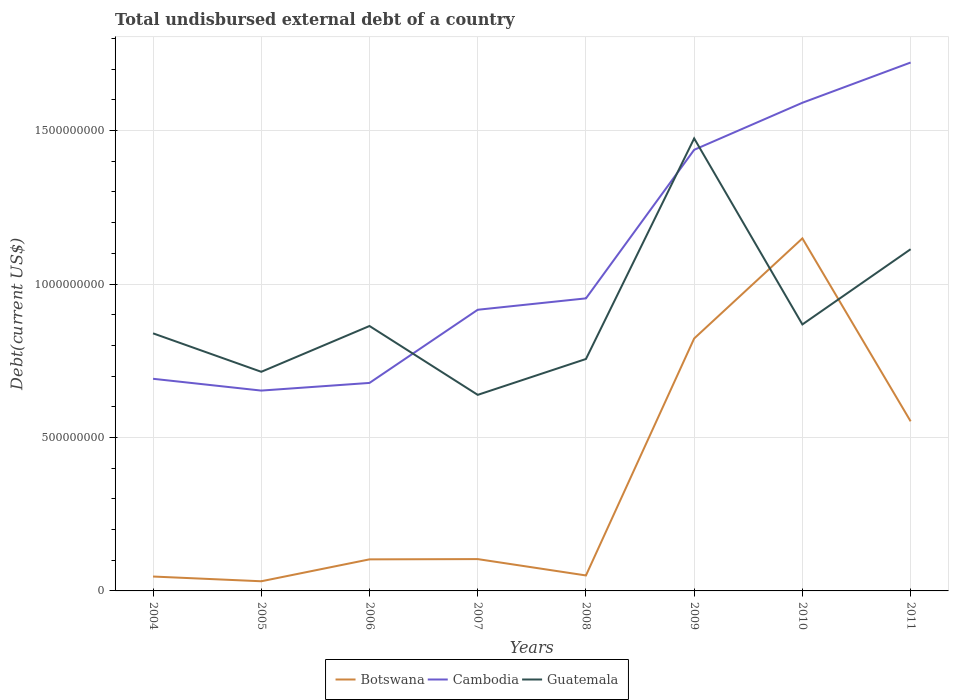Does the line corresponding to Botswana intersect with the line corresponding to Guatemala?
Make the answer very short. Yes. Across all years, what is the maximum total undisbursed external debt in Botswana?
Give a very brief answer. 3.15e+07. In which year was the total undisbursed external debt in Guatemala maximum?
Provide a succinct answer. 2007. What is the total total undisbursed external debt in Guatemala in the graph?
Your answer should be compact. -1.54e+08. What is the difference between the highest and the second highest total undisbursed external debt in Guatemala?
Offer a very short reply. 8.36e+08. How many years are there in the graph?
Offer a terse response. 8. Are the values on the major ticks of Y-axis written in scientific E-notation?
Ensure brevity in your answer.  No. Does the graph contain any zero values?
Provide a short and direct response. No. Where does the legend appear in the graph?
Offer a very short reply. Bottom center. How are the legend labels stacked?
Provide a short and direct response. Horizontal. What is the title of the graph?
Provide a short and direct response. Total undisbursed external debt of a country. What is the label or title of the X-axis?
Keep it short and to the point. Years. What is the label or title of the Y-axis?
Offer a terse response. Debt(current US$). What is the Debt(current US$) in Botswana in 2004?
Offer a very short reply. 4.69e+07. What is the Debt(current US$) of Cambodia in 2004?
Your response must be concise. 6.91e+08. What is the Debt(current US$) in Guatemala in 2004?
Offer a terse response. 8.39e+08. What is the Debt(current US$) in Botswana in 2005?
Make the answer very short. 3.15e+07. What is the Debt(current US$) of Cambodia in 2005?
Give a very brief answer. 6.53e+08. What is the Debt(current US$) in Guatemala in 2005?
Your response must be concise. 7.14e+08. What is the Debt(current US$) in Botswana in 2006?
Your answer should be compact. 1.03e+08. What is the Debt(current US$) in Cambodia in 2006?
Keep it short and to the point. 6.78e+08. What is the Debt(current US$) in Guatemala in 2006?
Offer a terse response. 8.63e+08. What is the Debt(current US$) in Botswana in 2007?
Provide a succinct answer. 1.04e+08. What is the Debt(current US$) of Cambodia in 2007?
Offer a very short reply. 9.16e+08. What is the Debt(current US$) in Guatemala in 2007?
Provide a short and direct response. 6.39e+08. What is the Debt(current US$) of Botswana in 2008?
Ensure brevity in your answer.  5.04e+07. What is the Debt(current US$) of Cambodia in 2008?
Your answer should be compact. 9.53e+08. What is the Debt(current US$) in Guatemala in 2008?
Your answer should be compact. 7.56e+08. What is the Debt(current US$) in Botswana in 2009?
Your answer should be very brief. 8.23e+08. What is the Debt(current US$) of Cambodia in 2009?
Offer a terse response. 1.44e+09. What is the Debt(current US$) in Guatemala in 2009?
Make the answer very short. 1.47e+09. What is the Debt(current US$) in Botswana in 2010?
Keep it short and to the point. 1.15e+09. What is the Debt(current US$) of Cambodia in 2010?
Your answer should be very brief. 1.59e+09. What is the Debt(current US$) of Guatemala in 2010?
Provide a short and direct response. 8.68e+08. What is the Debt(current US$) in Botswana in 2011?
Provide a short and direct response. 5.53e+08. What is the Debt(current US$) in Cambodia in 2011?
Offer a terse response. 1.72e+09. What is the Debt(current US$) in Guatemala in 2011?
Offer a terse response. 1.11e+09. Across all years, what is the maximum Debt(current US$) in Botswana?
Offer a very short reply. 1.15e+09. Across all years, what is the maximum Debt(current US$) in Cambodia?
Your answer should be very brief. 1.72e+09. Across all years, what is the maximum Debt(current US$) in Guatemala?
Your answer should be very brief. 1.47e+09. Across all years, what is the minimum Debt(current US$) in Botswana?
Offer a terse response. 3.15e+07. Across all years, what is the minimum Debt(current US$) of Cambodia?
Keep it short and to the point. 6.53e+08. Across all years, what is the minimum Debt(current US$) of Guatemala?
Offer a terse response. 6.39e+08. What is the total Debt(current US$) in Botswana in the graph?
Your response must be concise. 2.86e+09. What is the total Debt(current US$) in Cambodia in the graph?
Your response must be concise. 8.64e+09. What is the total Debt(current US$) in Guatemala in the graph?
Provide a succinct answer. 7.27e+09. What is the difference between the Debt(current US$) in Botswana in 2004 and that in 2005?
Provide a short and direct response. 1.54e+07. What is the difference between the Debt(current US$) in Cambodia in 2004 and that in 2005?
Offer a very short reply. 3.84e+07. What is the difference between the Debt(current US$) of Guatemala in 2004 and that in 2005?
Provide a succinct answer. 1.25e+08. What is the difference between the Debt(current US$) in Botswana in 2004 and that in 2006?
Provide a succinct answer. -5.59e+07. What is the difference between the Debt(current US$) in Cambodia in 2004 and that in 2006?
Provide a short and direct response. 1.35e+07. What is the difference between the Debt(current US$) in Guatemala in 2004 and that in 2006?
Provide a short and direct response. -2.39e+07. What is the difference between the Debt(current US$) in Botswana in 2004 and that in 2007?
Make the answer very short. -5.68e+07. What is the difference between the Debt(current US$) of Cambodia in 2004 and that in 2007?
Offer a very short reply. -2.25e+08. What is the difference between the Debt(current US$) of Guatemala in 2004 and that in 2007?
Your answer should be compact. 2.00e+08. What is the difference between the Debt(current US$) of Botswana in 2004 and that in 2008?
Provide a succinct answer. -3.52e+06. What is the difference between the Debt(current US$) of Cambodia in 2004 and that in 2008?
Your response must be concise. -2.62e+08. What is the difference between the Debt(current US$) of Guatemala in 2004 and that in 2008?
Give a very brief answer. 8.36e+07. What is the difference between the Debt(current US$) of Botswana in 2004 and that in 2009?
Make the answer very short. -7.76e+08. What is the difference between the Debt(current US$) in Cambodia in 2004 and that in 2009?
Your answer should be compact. -7.46e+08. What is the difference between the Debt(current US$) of Guatemala in 2004 and that in 2009?
Ensure brevity in your answer.  -6.35e+08. What is the difference between the Debt(current US$) of Botswana in 2004 and that in 2010?
Provide a short and direct response. -1.10e+09. What is the difference between the Debt(current US$) in Cambodia in 2004 and that in 2010?
Offer a very short reply. -8.99e+08. What is the difference between the Debt(current US$) of Guatemala in 2004 and that in 2010?
Provide a succinct answer. -2.90e+07. What is the difference between the Debt(current US$) in Botswana in 2004 and that in 2011?
Your answer should be very brief. -5.06e+08. What is the difference between the Debt(current US$) of Cambodia in 2004 and that in 2011?
Your answer should be very brief. -1.03e+09. What is the difference between the Debt(current US$) in Guatemala in 2004 and that in 2011?
Make the answer very short. -2.74e+08. What is the difference between the Debt(current US$) in Botswana in 2005 and that in 2006?
Your answer should be compact. -7.14e+07. What is the difference between the Debt(current US$) of Cambodia in 2005 and that in 2006?
Your response must be concise. -2.49e+07. What is the difference between the Debt(current US$) of Guatemala in 2005 and that in 2006?
Provide a short and direct response. -1.49e+08. What is the difference between the Debt(current US$) in Botswana in 2005 and that in 2007?
Ensure brevity in your answer.  -7.22e+07. What is the difference between the Debt(current US$) in Cambodia in 2005 and that in 2007?
Keep it short and to the point. -2.63e+08. What is the difference between the Debt(current US$) of Guatemala in 2005 and that in 2007?
Provide a succinct answer. 7.51e+07. What is the difference between the Debt(current US$) of Botswana in 2005 and that in 2008?
Your response must be concise. -1.90e+07. What is the difference between the Debt(current US$) of Cambodia in 2005 and that in 2008?
Keep it short and to the point. -3.00e+08. What is the difference between the Debt(current US$) in Guatemala in 2005 and that in 2008?
Ensure brevity in your answer.  -4.17e+07. What is the difference between the Debt(current US$) of Botswana in 2005 and that in 2009?
Keep it short and to the point. -7.91e+08. What is the difference between the Debt(current US$) in Cambodia in 2005 and that in 2009?
Keep it short and to the point. -7.85e+08. What is the difference between the Debt(current US$) in Guatemala in 2005 and that in 2009?
Keep it short and to the point. -7.60e+08. What is the difference between the Debt(current US$) of Botswana in 2005 and that in 2010?
Offer a very short reply. -1.12e+09. What is the difference between the Debt(current US$) of Cambodia in 2005 and that in 2010?
Provide a succinct answer. -9.38e+08. What is the difference between the Debt(current US$) of Guatemala in 2005 and that in 2010?
Your answer should be very brief. -1.54e+08. What is the difference between the Debt(current US$) of Botswana in 2005 and that in 2011?
Make the answer very short. -5.21e+08. What is the difference between the Debt(current US$) in Cambodia in 2005 and that in 2011?
Provide a succinct answer. -1.07e+09. What is the difference between the Debt(current US$) in Guatemala in 2005 and that in 2011?
Provide a succinct answer. -3.99e+08. What is the difference between the Debt(current US$) in Botswana in 2006 and that in 2007?
Give a very brief answer. -8.49e+05. What is the difference between the Debt(current US$) in Cambodia in 2006 and that in 2007?
Keep it short and to the point. -2.38e+08. What is the difference between the Debt(current US$) in Guatemala in 2006 and that in 2007?
Ensure brevity in your answer.  2.24e+08. What is the difference between the Debt(current US$) in Botswana in 2006 and that in 2008?
Provide a short and direct response. 5.24e+07. What is the difference between the Debt(current US$) of Cambodia in 2006 and that in 2008?
Offer a very short reply. -2.76e+08. What is the difference between the Debt(current US$) in Guatemala in 2006 and that in 2008?
Give a very brief answer. 1.08e+08. What is the difference between the Debt(current US$) of Botswana in 2006 and that in 2009?
Ensure brevity in your answer.  -7.20e+08. What is the difference between the Debt(current US$) in Cambodia in 2006 and that in 2009?
Provide a short and direct response. -7.60e+08. What is the difference between the Debt(current US$) in Guatemala in 2006 and that in 2009?
Your answer should be compact. -6.11e+08. What is the difference between the Debt(current US$) in Botswana in 2006 and that in 2010?
Give a very brief answer. -1.05e+09. What is the difference between the Debt(current US$) in Cambodia in 2006 and that in 2010?
Give a very brief answer. -9.13e+08. What is the difference between the Debt(current US$) of Guatemala in 2006 and that in 2010?
Your answer should be very brief. -5.10e+06. What is the difference between the Debt(current US$) of Botswana in 2006 and that in 2011?
Offer a very short reply. -4.50e+08. What is the difference between the Debt(current US$) in Cambodia in 2006 and that in 2011?
Offer a terse response. -1.04e+09. What is the difference between the Debt(current US$) of Guatemala in 2006 and that in 2011?
Keep it short and to the point. -2.50e+08. What is the difference between the Debt(current US$) of Botswana in 2007 and that in 2008?
Keep it short and to the point. 5.33e+07. What is the difference between the Debt(current US$) of Cambodia in 2007 and that in 2008?
Make the answer very short. -3.71e+07. What is the difference between the Debt(current US$) of Guatemala in 2007 and that in 2008?
Your response must be concise. -1.17e+08. What is the difference between the Debt(current US$) in Botswana in 2007 and that in 2009?
Provide a short and direct response. -7.19e+08. What is the difference between the Debt(current US$) in Cambodia in 2007 and that in 2009?
Your answer should be compact. -5.21e+08. What is the difference between the Debt(current US$) of Guatemala in 2007 and that in 2009?
Offer a very short reply. -8.36e+08. What is the difference between the Debt(current US$) in Botswana in 2007 and that in 2010?
Provide a succinct answer. -1.05e+09. What is the difference between the Debt(current US$) of Cambodia in 2007 and that in 2010?
Keep it short and to the point. -6.74e+08. What is the difference between the Debt(current US$) in Guatemala in 2007 and that in 2010?
Offer a terse response. -2.29e+08. What is the difference between the Debt(current US$) of Botswana in 2007 and that in 2011?
Offer a terse response. -4.49e+08. What is the difference between the Debt(current US$) in Cambodia in 2007 and that in 2011?
Make the answer very short. -8.06e+08. What is the difference between the Debt(current US$) in Guatemala in 2007 and that in 2011?
Offer a terse response. -4.75e+08. What is the difference between the Debt(current US$) of Botswana in 2008 and that in 2009?
Your answer should be very brief. -7.72e+08. What is the difference between the Debt(current US$) in Cambodia in 2008 and that in 2009?
Your answer should be compact. -4.84e+08. What is the difference between the Debt(current US$) in Guatemala in 2008 and that in 2009?
Make the answer very short. -7.19e+08. What is the difference between the Debt(current US$) in Botswana in 2008 and that in 2010?
Your answer should be compact. -1.10e+09. What is the difference between the Debt(current US$) in Cambodia in 2008 and that in 2010?
Your answer should be very brief. -6.37e+08. What is the difference between the Debt(current US$) of Guatemala in 2008 and that in 2010?
Give a very brief answer. -1.13e+08. What is the difference between the Debt(current US$) in Botswana in 2008 and that in 2011?
Your response must be concise. -5.02e+08. What is the difference between the Debt(current US$) in Cambodia in 2008 and that in 2011?
Keep it short and to the point. -7.68e+08. What is the difference between the Debt(current US$) of Guatemala in 2008 and that in 2011?
Provide a short and direct response. -3.58e+08. What is the difference between the Debt(current US$) in Botswana in 2009 and that in 2010?
Ensure brevity in your answer.  -3.26e+08. What is the difference between the Debt(current US$) of Cambodia in 2009 and that in 2010?
Offer a very short reply. -1.53e+08. What is the difference between the Debt(current US$) in Guatemala in 2009 and that in 2010?
Ensure brevity in your answer.  6.06e+08. What is the difference between the Debt(current US$) of Botswana in 2009 and that in 2011?
Make the answer very short. 2.70e+08. What is the difference between the Debt(current US$) of Cambodia in 2009 and that in 2011?
Make the answer very short. -2.84e+08. What is the difference between the Debt(current US$) of Guatemala in 2009 and that in 2011?
Your response must be concise. 3.61e+08. What is the difference between the Debt(current US$) in Botswana in 2010 and that in 2011?
Provide a short and direct response. 5.96e+08. What is the difference between the Debt(current US$) of Cambodia in 2010 and that in 2011?
Offer a terse response. -1.31e+08. What is the difference between the Debt(current US$) of Guatemala in 2010 and that in 2011?
Provide a short and direct response. -2.45e+08. What is the difference between the Debt(current US$) of Botswana in 2004 and the Debt(current US$) of Cambodia in 2005?
Give a very brief answer. -6.06e+08. What is the difference between the Debt(current US$) of Botswana in 2004 and the Debt(current US$) of Guatemala in 2005?
Give a very brief answer. -6.67e+08. What is the difference between the Debt(current US$) of Cambodia in 2004 and the Debt(current US$) of Guatemala in 2005?
Ensure brevity in your answer.  -2.28e+07. What is the difference between the Debt(current US$) of Botswana in 2004 and the Debt(current US$) of Cambodia in 2006?
Provide a succinct answer. -6.31e+08. What is the difference between the Debt(current US$) in Botswana in 2004 and the Debt(current US$) in Guatemala in 2006?
Make the answer very short. -8.16e+08. What is the difference between the Debt(current US$) in Cambodia in 2004 and the Debt(current US$) in Guatemala in 2006?
Your answer should be compact. -1.72e+08. What is the difference between the Debt(current US$) of Botswana in 2004 and the Debt(current US$) of Cambodia in 2007?
Give a very brief answer. -8.69e+08. What is the difference between the Debt(current US$) in Botswana in 2004 and the Debt(current US$) in Guatemala in 2007?
Give a very brief answer. -5.92e+08. What is the difference between the Debt(current US$) in Cambodia in 2004 and the Debt(current US$) in Guatemala in 2007?
Offer a terse response. 5.24e+07. What is the difference between the Debt(current US$) in Botswana in 2004 and the Debt(current US$) in Cambodia in 2008?
Keep it short and to the point. -9.06e+08. What is the difference between the Debt(current US$) of Botswana in 2004 and the Debt(current US$) of Guatemala in 2008?
Provide a succinct answer. -7.09e+08. What is the difference between the Debt(current US$) in Cambodia in 2004 and the Debt(current US$) in Guatemala in 2008?
Ensure brevity in your answer.  -6.45e+07. What is the difference between the Debt(current US$) of Botswana in 2004 and the Debt(current US$) of Cambodia in 2009?
Your answer should be compact. -1.39e+09. What is the difference between the Debt(current US$) in Botswana in 2004 and the Debt(current US$) in Guatemala in 2009?
Offer a terse response. -1.43e+09. What is the difference between the Debt(current US$) of Cambodia in 2004 and the Debt(current US$) of Guatemala in 2009?
Your answer should be compact. -7.83e+08. What is the difference between the Debt(current US$) of Botswana in 2004 and the Debt(current US$) of Cambodia in 2010?
Provide a short and direct response. -1.54e+09. What is the difference between the Debt(current US$) in Botswana in 2004 and the Debt(current US$) in Guatemala in 2010?
Your answer should be compact. -8.21e+08. What is the difference between the Debt(current US$) in Cambodia in 2004 and the Debt(current US$) in Guatemala in 2010?
Offer a terse response. -1.77e+08. What is the difference between the Debt(current US$) in Botswana in 2004 and the Debt(current US$) in Cambodia in 2011?
Your answer should be compact. -1.67e+09. What is the difference between the Debt(current US$) of Botswana in 2004 and the Debt(current US$) of Guatemala in 2011?
Offer a terse response. -1.07e+09. What is the difference between the Debt(current US$) in Cambodia in 2004 and the Debt(current US$) in Guatemala in 2011?
Provide a short and direct response. -4.22e+08. What is the difference between the Debt(current US$) of Botswana in 2005 and the Debt(current US$) of Cambodia in 2006?
Keep it short and to the point. -6.46e+08. What is the difference between the Debt(current US$) in Botswana in 2005 and the Debt(current US$) in Guatemala in 2006?
Provide a short and direct response. -8.32e+08. What is the difference between the Debt(current US$) of Cambodia in 2005 and the Debt(current US$) of Guatemala in 2006?
Your answer should be compact. -2.10e+08. What is the difference between the Debt(current US$) in Botswana in 2005 and the Debt(current US$) in Cambodia in 2007?
Keep it short and to the point. -8.85e+08. What is the difference between the Debt(current US$) in Botswana in 2005 and the Debt(current US$) in Guatemala in 2007?
Give a very brief answer. -6.07e+08. What is the difference between the Debt(current US$) in Cambodia in 2005 and the Debt(current US$) in Guatemala in 2007?
Keep it short and to the point. 1.39e+07. What is the difference between the Debt(current US$) in Botswana in 2005 and the Debt(current US$) in Cambodia in 2008?
Offer a terse response. -9.22e+08. What is the difference between the Debt(current US$) of Botswana in 2005 and the Debt(current US$) of Guatemala in 2008?
Provide a succinct answer. -7.24e+08. What is the difference between the Debt(current US$) in Cambodia in 2005 and the Debt(current US$) in Guatemala in 2008?
Your answer should be compact. -1.03e+08. What is the difference between the Debt(current US$) in Botswana in 2005 and the Debt(current US$) in Cambodia in 2009?
Your response must be concise. -1.41e+09. What is the difference between the Debt(current US$) of Botswana in 2005 and the Debt(current US$) of Guatemala in 2009?
Your answer should be compact. -1.44e+09. What is the difference between the Debt(current US$) of Cambodia in 2005 and the Debt(current US$) of Guatemala in 2009?
Offer a terse response. -8.22e+08. What is the difference between the Debt(current US$) in Botswana in 2005 and the Debt(current US$) in Cambodia in 2010?
Your response must be concise. -1.56e+09. What is the difference between the Debt(current US$) of Botswana in 2005 and the Debt(current US$) of Guatemala in 2010?
Provide a succinct answer. -8.37e+08. What is the difference between the Debt(current US$) of Cambodia in 2005 and the Debt(current US$) of Guatemala in 2010?
Your answer should be compact. -2.16e+08. What is the difference between the Debt(current US$) of Botswana in 2005 and the Debt(current US$) of Cambodia in 2011?
Offer a terse response. -1.69e+09. What is the difference between the Debt(current US$) of Botswana in 2005 and the Debt(current US$) of Guatemala in 2011?
Your response must be concise. -1.08e+09. What is the difference between the Debt(current US$) of Cambodia in 2005 and the Debt(current US$) of Guatemala in 2011?
Ensure brevity in your answer.  -4.61e+08. What is the difference between the Debt(current US$) of Botswana in 2006 and the Debt(current US$) of Cambodia in 2007?
Give a very brief answer. -8.13e+08. What is the difference between the Debt(current US$) in Botswana in 2006 and the Debt(current US$) in Guatemala in 2007?
Provide a succinct answer. -5.36e+08. What is the difference between the Debt(current US$) of Cambodia in 2006 and the Debt(current US$) of Guatemala in 2007?
Your answer should be compact. 3.89e+07. What is the difference between the Debt(current US$) of Botswana in 2006 and the Debt(current US$) of Cambodia in 2008?
Your response must be concise. -8.50e+08. What is the difference between the Debt(current US$) in Botswana in 2006 and the Debt(current US$) in Guatemala in 2008?
Keep it short and to the point. -6.53e+08. What is the difference between the Debt(current US$) in Cambodia in 2006 and the Debt(current US$) in Guatemala in 2008?
Provide a succinct answer. -7.80e+07. What is the difference between the Debt(current US$) of Botswana in 2006 and the Debt(current US$) of Cambodia in 2009?
Keep it short and to the point. -1.33e+09. What is the difference between the Debt(current US$) of Botswana in 2006 and the Debt(current US$) of Guatemala in 2009?
Give a very brief answer. -1.37e+09. What is the difference between the Debt(current US$) in Cambodia in 2006 and the Debt(current US$) in Guatemala in 2009?
Your response must be concise. -7.97e+08. What is the difference between the Debt(current US$) in Botswana in 2006 and the Debt(current US$) in Cambodia in 2010?
Keep it short and to the point. -1.49e+09. What is the difference between the Debt(current US$) in Botswana in 2006 and the Debt(current US$) in Guatemala in 2010?
Keep it short and to the point. -7.65e+08. What is the difference between the Debt(current US$) of Cambodia in 2006 and the Debt(current US$) of Guatemala in 2010?
Offer a terse response. -1.91e+08. What is the difference between the Debt(current US$) in Botswana in 2006 and the Debt(current US$) in Cambodia in 2011?
Give a very brief answer. -1.62e+09. What is the difference between the Debt(current US$) in Botswana in 2006 and the Debt(current US$) in Guatemala in 2011?
Offer a terse response. -1.01e+09. What is the difference between the Debt(current US$) of Cambodia in 2006 and the Debt(current US$) of Guatemala in 2011?
Offer a terse response. -4.36e+08. What is the difference between the Debt(current US$) in Botswana in 2007 and the Debt(current US$) in Cambodia in 2008?
Provide a succinct answer. -8.50e+08. What is the difference between the Debt(current US$) in Botswana in 2007 and the Debt(current US$) in Guatemala in 2008?
Provide a short and direct response. -6.52e+08. What is the difference between the Debt(current US$) of Cambodia in 2007 and the Debt(current US$) of Guatemala in 2008?
Make the answer very short. 1.60e+08. What is the difference between the Debt(current US$) of Botswana in 2007 and the Debt(current US$) of Cambodia in 2009?
Keep it short and to the point. -1.33e+09. What is the difference between the Debt(current US$) in Botswana in 2007 and the Debt(current US$) in Guatemala in 2009?
Give a very brief answer. -1.37e+09. What is the difference between the Debt(current US$) in Cambodia in 2007 and the Debt(current US$) in Guatemala in 2009?
Provide a short and direct response. -5.58e+08. What is the difference between the Debt(current US$) of Botswana in 2007 and the Debt(current US$) of Cambodia in 2010?
Ensure brevity in your answer.  -1.49e+09. What is the difference between the Debt(current US$) of Botswana in 2007 and the Debt(current US$) of Guatemala in 2010?
Your answer should be very brief. -7.65e+08. What is the difference between the Debt(current US$) in Cambodia in 2007 and the Debt(current US$) in Guatemala in 2010?
Offer a very short reply. 4.78e+07. What is the difference between the Debt(current US$) of Botswana in 2007 and the Debt(current US$) of Cambodia in 2011?
Your response must be concise. -1.62e+09. What is the difference between the Debt(current US$) of Botswana in 2007 and the Debt(current US$) of Guatemala in 2011?
Provide a succinct answer. -1.01e+09. What is the difference between the Debt(current US$) of Cambodia in 2007 and the Debt(current US$) of Guatemala in 2011?
Your response must be concise. -1.97e+08. What is the difference between the Debt(current US$) in Botswana in 2008 and the Debt(current US$) in Cambodia in 2009?
Offer a very short reply. -1.39e+09. What is the difference between the Debt(current US$) in Botswana in 2008 and the Debt(current US$) in Guatemala in 2009?
Provide a short and direct response. -1.42e+09. What is the difference between the Debt(current US$) in Cambodia in 2008 and the Debt(current US$) in Guatemala in 2009?
Ensure brevity in your answer.  -5.21e+08. What is the difference between the Debt(current US$) of Botswana in 2008 and the Debt(current US$) of Cambodia in 2010?
Your answer should be very brief. -1.54e+09. What is the difference between the Debt(current US$) of Botswana in 2008 and the Debt(current US$) of Guatemala in 2010?
Give a very brief answer. -8.18e+08. What is the difference between the Debt(current US$) of Cambodia in 2008 and the Debt(current US$) of Guatemala in 2010?
Your answer should be very brief. 8.49e+07. What is the difference between the Debt(current US$) in Botswana in 2008 and the Debt(current US$) in Cambodia in 2011?
Your answer should be compact. -1.67e+09. What is the difference between the Debt(current US$) of Botswana in 2008 and the Debt(current US$) of Guatemala in 2011?
Provide a succinct answer. -1.06e+09. What is the difference between the Debt(current US$) of Cambodia in 2008 and the Debt(current US$) of Guatemala in 2011?
Keep it short and to the point. -1.60e+08. What is the difference between the Debt(current US$) of Botswana in 2009 and the Debt(current US$) of Cambodia in 2010?
Keep it short and to the point. -7.68e+08. What is the difference between the Debt(current US$) of Botswana in 2009 and the Debt(current US$) of Guatemala in 2010?
Offer a very short reply. -4.57e+07. What is the difference between the Debt(current US$) in Cambodia in 2009 and the Debt(current US$) in Guatemala in 2010?
Provide a succinct answer. 5.69e+08. What is the difference between the Debt(current US$) of Botswana in 2009 and the Debt(current US$) of Cambodia in 2011?
Make the answer very short. -8.99e+08. What is the difference between the Debt(current US$) in Botswana in 2009 and the Debt(current US$) in Guatemala in 2011?
Offer a very short reply. -2.91e+08. What is the difference between the Debt(current US$) of Cambodia in 2009 and the Debt(current US$) of Guatemala in 2011?
Offer a terse response. 3.24e+08. What is the difference between the Debt(current US$) in Botswana in 2010 and the Debt(current US$) in Cambodia in 2011?
Provide a succinct answer. -5.73e+08. What is the difference between the Debt(current US$) of Botswana in 2010 and the Debt(current US$) of Guatemala in 2011?
Keep it short and to the point. 3.53e+07. What is the difference between the Debt(current US$) in Cambodia in 2010 and the Debt(current US$) in Guatemala in 2011?
Provide a succinct answer. 4.77e+08. What is the average Debt(current US$) in Botswana per year?
Ensure brevity in your answer.  3.57e+08. What is the average Debt(current US$) in Cambodia per year?
Provide a short and direct response. 1.08e+09. What is the average Debt(current US$) in Guatemala per year?
Give a very brief answer. 9.08e+08. In the year 2004, what is the difference between the Debt(current US$) in Botswana and Debt(current US$) in Cambodia?
Keep it short and to the point. -6.44e+08. In the year 2004, what is the difference between the Debt(current US$) of Botswana and Debt(current US$) of Guatemala?
Your answer should be very brief. -7.92e+08. In the year 2004, what is the difference between the Debt(current US$) in Cambodia and Debt(current US$) in Guatemala?
Provide a succinct answer. -1.48e+08. In the year 2005, what is the difference between the Debt(current US$) of Botswana and Debt(current US$) of Cambodia?
Provide a succinct answer. -6.21e+08. In the year 2005, what is the difference between the Debt(current US$) of Botswana and Debt(current US$) of Guatemala?
Your answer should be compact. -6.83e+08. In the year 2005, what is the difference between the Debt(current US$) of Cambodia and Debt(current US$) of Guatemala?
Offer a terse response. -6.12e+07. In the year 2006, what is the difference between the Debt(current US$) of Botswana and Debt(current US$) of Cambodia?
Keep it short and to the point. -5.75e+08. In the year 2006, what is the difference between the Debt(current US$) of Botswana and Debt(current US$) of Guatemala?
Ensure brevity in your answer.  -7.60e+08. In the year 2006, what is the difference between the Debt(current US$) of Cambodia and Debt(current US$) of Guatemala?
Ensure brevity in your answer.  -1.85e+08. In the year 2007, what is the difference between the Debt(current US$) of Botswana and Debt(current US$) of Cambodia?
Keep it short and to the point. -8.12e+08. In the year 2007, what is the difference between the Debt(current US$) of Botswana and Debt(current US$) of Guatemala?
Provide a short and direct response. -5.35e+08. In the year 2007, what is the difference between the Debt(current US$) of Cambodia and Debt(current US$) of Guatemala?
Ensure brevity in your answer.  2.77e+08. In the year 2008, what is the difference between the Debt(current US$) of Botswana and Debt(current US$) of Cambodia?
Make the answer very short. -9.03e+08. In the year 2008, what is the difference between the Debt(current US$) in Botswana and Debt(current US$) in Guatemala?
Your answer should be very brief. -7.05e+08. In the year 2008, what is the difference between the Debt(current US$) of Cambodia and Debt(current US$) of Guatemala?
Offer a very short reply. 1.98e+08. In the year 2009, what is the difference between the Debt(current US$) in Botswana and Debt(current US$) in Cambodia?
Keep it short and to the point. -6.15e+08. In the year 2009, what is the difference between the Debt(current US$) of Botswana and Debt(current US$) of Guatemala?
Keep it short and to the point. -6.52e+08. In the year 2009, what is the difference between the Debt(current US$) of Cambodia and Debt(current US$) of Guatemala?
Offer a very short reply. -3.71e+07. In the year 2010, what is the difference between the Debt(current US$) of Botswana and Debt(current US$) of Cambodia?
Offer a terse response. -4.42e+08. In the year 2010, what is the difference between the Debt(current US$) of Botswana and Debt(current US$) of Guatemala?
Give a very brief answer. 2.80e+08. In the year 2010, what is the difference between the Debt(current US$) in Cambodia and Debt(current US$) in Guatemala?
Give a very brief answer. 7.22e+08. In the year 2011, what is the difference between the Debt(current US$) in Botswana and Debt(current US$) in Cambodia?
Your answer should be compact. -1.17e+09. In the year 2011, what is the difference between the Debt(current US$) in Botswana and Debt(current US$) in Guatemala?
Ensure brevity in your answer.  -5.61e+08. In the year 2011, what is the difference between the Debt(current US$) in Cambodia and Debt(current US$) in Guatemala?
Offer a very short reply. 6.08e+08. What is the ratio of the Debt(current US$) of Botswana in 2004 to that in 2005?
Offer a terse response. 1.49. What is the ratio of the Debt(current US$) in Cambodia in 2004 to that in 2005?
Give a very brief answer. 1.06. What is the ratio of the Debt(current US$) in Guatemala in 2004 to that in 2005?
Give a very brief answer. 1.18. What is the ratio of the Debt(current US$) of Botswana in 2004 to that in 2006?
Your answer should be very brief. 0.46. What is the ratio of the Debt(current US$) of Cambodia in 2004 to that in 2006?
Provide a succinct answer. 1.02. What is the ratio of the Debt(current US$) of Guatemala in 2004 to that in 2006?
Offer a very short reply. 0.97. What is the ratio of the Debt(current US$) of Botswana in 2004 to that in 2007?
Offer a very short reply. 0.45. What is the ratio of the Debt(current US$) of Cambodia in 2004 to that in 2007?
Your response must be concise. 0.75. What is the ratio of the Debt(current US$) in Guatemala in 2004 to that in 2007?
Make the answer very short. 1.31. What is the ratio of the Debt(current US$) of Botswana in 2004 to that in 2008?
Your response must be concise. 0.93. What is the ratio of the Debt(current US$) in Cambodia in 2004 to that in 2008?
Make the answer very short. 0.73. What is the ratio of the Debt(current US$) in Guatemala in 2004 to that in 2008?
Provide a short and direct response. 1.11. What is the ratio of the Debt(current US$) of Botswana in 2004 to that in 2009?
Make the answer very short. 0.06. What is the ratio of the Debt(current US$) of Cambodia in 2004 to that in 2009?
Offer a very short reply. 0.48. What is the ratio of the Debt(current US$) of Guatemala in 2004 to that in 2009?
Your answer should be compact. 0.57. What is the ratio of the Debt(current US$) of Botswana in 2004 to that in 2010?
Your answer should be compact. 0.04. What is the ratio of the Debt(current US$) of Cambodia in 2004 to that in 2010?
Offer a terse response. 0.43. What is the ratio of the Debt(current US$) in Guatemala in 2004 to that in 2010?
Provide a short and direct response. 0.97. What is the ratio of the Debt(current US$) of Botswana in 2004 to that in 2011?
Your answer should be very brief. 0.08. What is the ratio of the Debt(current US$) in Cambodia in 2004 to that in 2011?
Your answer should be compact. 0.4. What is the ratio of the Debt(current US$) of Guatemala in 2004 to that in 2011?
Make the answer very short. 0.75. What is the ratio of the Debt(current US$) of Botswana in 2005 to that in 2006?
Your response must be concise. 0.31. What is the ratio of the Debt(current US$) in Cambodia in 2005 to that in 2006?
Offer a terse response. 0.96. What is the ratio of the Debt(current US$) in Guatemala in 2005 to that in 2006?
Offer a very short reply. 0.83. What is the ratio of the Debt(current US$) of Botswana in 2005 to that in 2007?
Offer a very short reply. 0.3. What is the ratio of the Debt(current US$) in Cambodia in 2005 to that in 2007?
Your answer should be very brief. 0.71. What is the ratio of the Debt(current US$) of Guatemala in 2005 to that in 2007?
Your answer should be compact. 1.12. What is the ratio of the Debt(current US$) of Botswana in 2005 to that in 2008?
Your response must be concise. 0.62. What is the ratio of the Debt(current US$) of Cambodia in 2005 to that in 2008?
Your answer should be compact. 0.68. What is the ratio of the Debt(current US$) in Guatemala in 2005 to that in 2008?
Make the answer very short. 0.94. What is the ratio of the Debt(current US$) in Botswana in 2005 to that in 2009?
Keep it short and to the point. 0.04. What is the ratio of the Debt(current US$) of Cambodia in 2005 to that in 2009?
Provide a succinct answer. 0.45. What is the ratio of the Debt(current US$) of Guatemala in 2005 to that in 2009?
Offer a terse response. 0.48. What is the ratio of the Debt(current US$) in Botswana in 2005 to that in 2010?
Offer a terse response. 0.03. What is the ratio of the Debt(current US$) of Cambodia in 2005 to that in 2010?
Provide a short and direct response. 0.41. What is the ratio of the Debt(current US$) in Guatemala in 2005 to that in 2010?
Ensure brevity in your answer.  0.82. What is the ratio of the Debt(current US$) in Botswana in 2005 to that in 2011?
Ensure brevity in your answer.  0.06. What is the ratio of the Debt(current US$) in Cambodia in 2005 to that in 2011?
Provide a succinct answer. 0.38. What is the ratio of the Debt(current US$) in Guatemala in 2005 to that in 2011?
Your answer should be compact. 0.64. What is the ratio of the Debt(current US$) of Cambodia in 2006 to that in 2007?
Offer a terse response. 0.74. What is the ratio of the Debt(current US$) in Guatemala in 2006 to that in 2007?
Make the answer very short. 1.35. What is the ratio of the Debt(current US$) of Botswana in 2006 to that in 2008?
Your answer should be very brief. 2.04. What is the ratio of the Debt(current US$) of Cambodia in 2006 to that in 2008?
Give a very brief answer. 0.71. What is the ratio of the Debt(current US$) of Guatemala in 2006 to that in 2008?
Keep it short and to the point. 1.14. What is the ratio of the Debt(current US$) of Cambodia in 2006 to that in 2009?
Your answer should be compact. 0.47. What is the ratio of the Debt(current US$) in Guatemala in 2006 to that in 2009?
Your answer should be very brief. 0.59. What is the ratio of the Debt(current US$) in Botswana in 2006 to that in 2010?
Your answer should be compact. 0.09. What is the ratio of the Debt(current US$) in Cambodia in 2006 to that in 2010?
Provide a succinct answer. 0.43. What is the ratio of the Debt(current US$) in Guatemala in 2006 to that in 2010?
Give a very brief answer. 0.99. What is the ratio of the Debt(current US$) of Botswana in 2006 to that in 2011?
Your answer should be very brief. 0.19. What is the ratio of the Debt(current US$) of Cambodia in 2006 to that in 2011?
Make the answer very short. 0.39. What is the ratio of the Debt(current US$) of Guatemala in 2006 to that in 2011?
Your answer should be compact. 0.78. What is the ratio of the Debt(current US$) of Botswana in 2007 to that in 2008?
Your answer should be very brief. 2.06. What is the ratio of the Debt(current US$) in Cambodia in 2007 to that in 2008?
Offer a terse response. 0.96. What is the ratio of the Debt(current US$) of Guatemala in 2007 to that in 2008?
Your answer should be compact. 0.85. What is the ratio of the Debt(current US$) of Botswana in 2007 to that in 2009?
Your answer should be very brief. 0.13. What is the ratio of the Debt(current US$) of Cambodia in 2007 to that in 2009?
Your response must be concise. 0.64. What is the ratio of the Debt(current US$) in Guatemala in 2007 to that in 2009?
Ensure brevity in your answer.  0.43. What is the ratio of the Debt(current US$) in Botswana in 2007 to that in 2010?
Give a very brief answer. 0.09. What is the ratio of the Debt(current US$) of Cambodia in 2007 to that in 2010?
Provide a succinct answer. 0.58. What is the ratio of the Debt(current US$) of Guatemala in 2007 to that in 2010?
Provide a succinct answer. 0.74. What is the ratio of the Debt(current US$) in Botswana in 2007 to that in 2011?
Keep it short and to the point. 0.19. What is the ratio of the Debt(current US$) in Cambodia in 2007 to that in 2011?
Offer a terse response. 0.53. What is the ratio of the Debt(current US$) of Guatemala in 2007 to that in 2011?
Ensure brevity in your answer.  0.57. What is the ratio of the Debt(current US$) of Botswana in 2008 to that in 2009?
Provide a succinct answer. 0.06. What is the ratio of the Debt(current US$) of Cambodia in 2008 to that in 2009?
Provide a succinct answer. 0.66. What is the ratio of the Debt(current US$) of Guatemala in 2008 to that in 2009?
Your response must be concise. 0.51. What is the ratio of the Debt(current US$) of Botswana in 2008 to that in 2010?
Your answer should be compact. 0.04. What is the ratio of the Debt(current US$) of Cambodia in 2008 to that in 2010?
Your response must be concise. 0.6. What is the ratio of the Debt(current US$) in Guatemala in 2008 to that in 2010?
Provide a short and direct response. 0.87. What is the ratio of the Debt(current US$) in Botswana in 2008 to that in 2011?
Provide a succinct answer. 0.09. What is the ratio of the Debt(current US$) in Cambodia in 2008 to that in 2011?
Provide a succinct answer. 0.55. What is the ratio of the Debt(current US$) of Guatemala in 2008 to that in 2011?
Make the answer very short. 0.68. What is the ratio of the Debt(current US$) of Botswana in 2009 to that in 2010?
Your answer should be compact. 0.72. What is the ratio of the Debt(current US$) in Cambodia in 2009 to that in 2010?
Give a very brief answer. 0.9. What is the ratio of the Debt(current US$) of Guatemala in 2009 to that in 2010?
Your answer should be compact. 1.7. What is the ratio of the Debt(current US$) of Botswana in 2009 to that in 2011?
Your answer should be very brief. 1.49. What is the ratio of the Debt(current US$) in Cambodia in 2009 to that in 2011?
Your answer should be very brief. 0.83. What is the ratio of the Debt(current US$) in Guatemala in 2009 to that in 2011?
Offer a terse response. 1.32. What is the ratio of the Debt(current US$) of Botswana in 2010 to that in 2011?
Give a very brief answer. 2.08. What is the ratio of the Debt(current US$) in Cambodia in 2010 to that in 2011?
Give a very brief answer. 0.92. What is the ratio of the Debt(current US$) of Guatemala in 2010 to that in 2011?
Ensure brevity in your answer.  0.78. What is the difference between the highest and the second highest Debt(current US$) in Botswana?
Provide a short and direct response. 3.26e+08. What is the difference between the highest and the second highest Debt(current US$) in Cambodia?
Make the answer very short. 1.31e+08. What is the difference between the highest and the second highest Debt(current US$) in Guatemala?
Make the answer very short. 3.61e+08. What is the difference between the highest and the lowest Debt(current US$) of Botswana?
Your answer should be very brief. 1.12e+09. What is the difference between the highest and the lowest Debt(current US$) in Cambodia?
Your answer should be very brief. 1.07e+09. What is the difference between the highest and the lowest Debt(current US$) of Guatemala?
Offer a very short reply. 8.36e+08. 